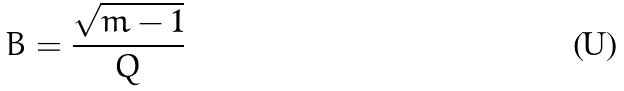Convert formula to latex. <formula><loc_0><loc_0><loc_500><loc_500>B = \frac { \sqrt { m - 1 } } { Q }</formula> 